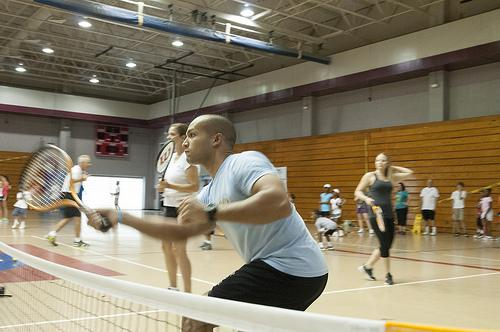Question: what sport is being played?
Choices:
A. Football.
B. Baseball.
C. Field hockey.
D. Tennis.
Answer with the letter. Answer: D Question: what is the man holding?
Choices:
A. A sandwich.
B. A spatula.
C. A tennis racket.
D. A book.
Answer with the letter. Answer: C Question: where is the game being played?
Choices:
A. In a gymnasium.
B. At the field behind the school.
C. In Colorado.
D. Shea Stadium.
Answer with the letter. Answer: A Question: what color are the man's shorts?
Choices:
A. Brown.
B. Black.
C. Blue.
D. Grey.
Answer with the letter. Answer: B Question: why is the man bent forward?
Choices:
A. He is coughing.
B. He wants to pet the little dog.
C. He dropped something and wants to pick it up.
D. He's about to hit the ball.
Answer with the letter. Answer: D Question: what are the brown wooden things in the back?
Choices:
A. Chairs.
B. Bleachers.
C. Sawhorses.
D. Beehives.
Answer with the letter. Answer: B 